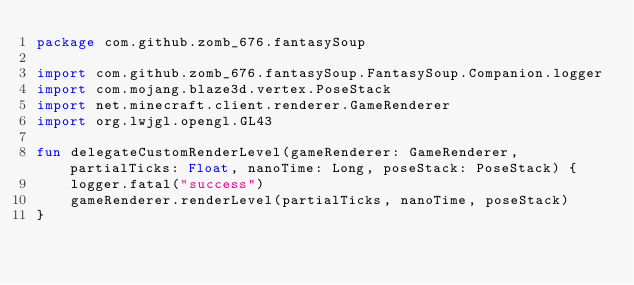<code> <loc_0><loc_0><loc_500><loc_500><_Kotlin_>package com.github.zomb_676.fantasySoup

import com.github.zomb_676.fantasySoup.FantasySoup.Companion.logger
import com.mojang.blaze3d.vertex.PoseStack
import net.minecraft.client.renderer.GameRenderer
import org.lwjgl.opengl.GL43

fun delegateCustomRenderLevel(gameRenderer: GameRenderer, partialTicks: Float, nanoTime: Long, poseStack: PoseStack) {
    logger.fatal("success")
    gameRenderer.renderLevel(partialTicks, nanoTime, poseStack)
}</code> 